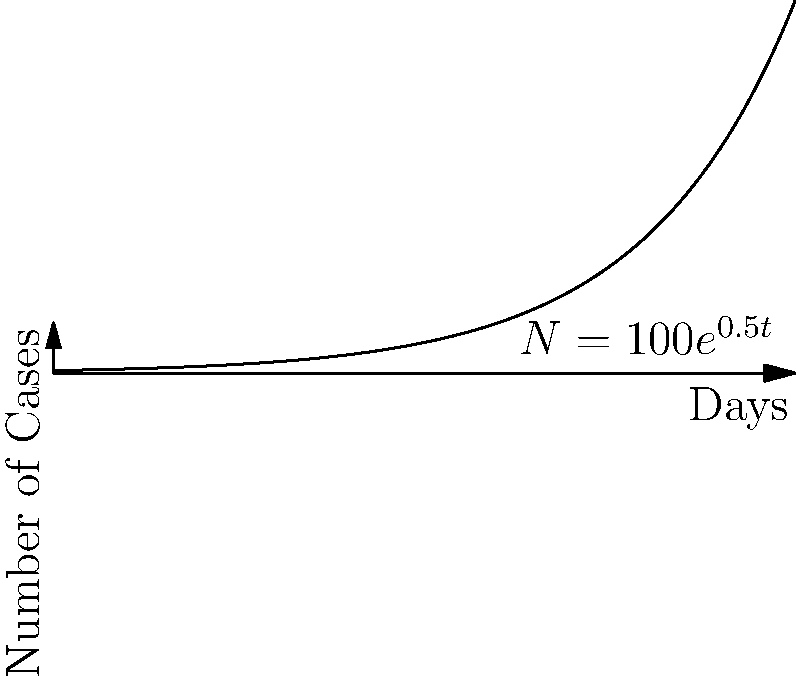As a concerned parent in Kano, you've been monitoring a local disease outbreak. The graph shows the spread of the disease over time, where $N = 100e^{0.5t}$ represents the number of cases after $t$ days. How many days will it take for the number of cases to reach 1000? To solve this problem, we need to use the given exponential function and solve for $t$ when $N = 1000$.

1) The function is given as $N = 100e^{0.5t}$

2) We want to find $t$ when $N = 1000$, so let's substitute this:
   $1000 = 100e^{0.5t}$

3) Divide both sides by 100:
   $10 = e^{0.5t}$

4) Take the natural logarithm of both sides:
   $\ln(10) = \ln(e^{0.5t})$

5) Simplify the right side using the properties of logarithms:
   $\ln(10) = 0.5t$

6) Solve for $t$ by dividing both sides by 0.5:
   $t = \frac{\ln(10)}{0.5} = 2\ln(10) \approx 4.605$

7) Since we're dealing with days, we need to round up to the nearest whole day.

Therefore, it will take 5 days for the number of cases to reach 1000.
Answer: 5 days 